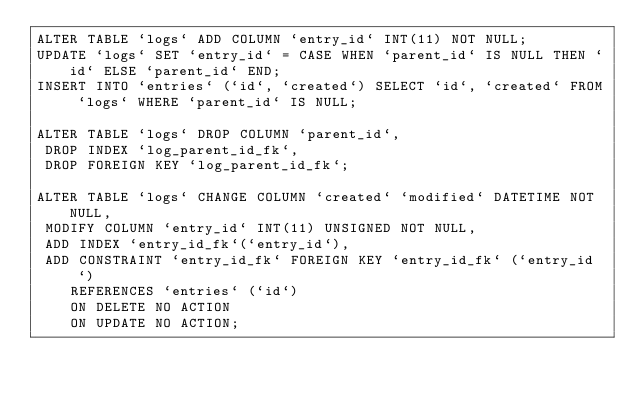Convert code to text. <code><loc_0><loc_0><loc_500><loc_500><_SQL_>ALTER TABLE `logs` ADD COLUMN `entry_id` INT(11) NOT NULL;
UPDATE `logs` SET `entry_id` = CASE WHEN `parent_id` IS NULL THEN `id` ELSE `parent_id` END;
INSERT INTO `entries` (`id`, `created`) SELECT `id`, `created` FROM `logs` WHERE `parent_id` IS NULL;

ALTER TABLE `logs` DROP COLUMN `parent_id`, 
 DROP INDEX `log_parent_id_fk`,
 DROP FOREIGN KEY `log_parent_id_fk`;

ALTER TABLE `logs` CHANGE COLUMN `created` `modified` DATETIME NOT NULL,
 MODIFY COLUMN `entry_id` INT(11) UNSIGNED NOT NULL,
 ADD INDEX `entry_id_fk`(`entry_id`),
 ADD CONSTRAINT `entry_id_fk` FOREIGN KEY `entry_id_fk` (`entry_id`)
    REFERENCES `entries` (`id`)
    ON DELETE NO ACTION
    ON UPDATE NO ACTION;</code> 